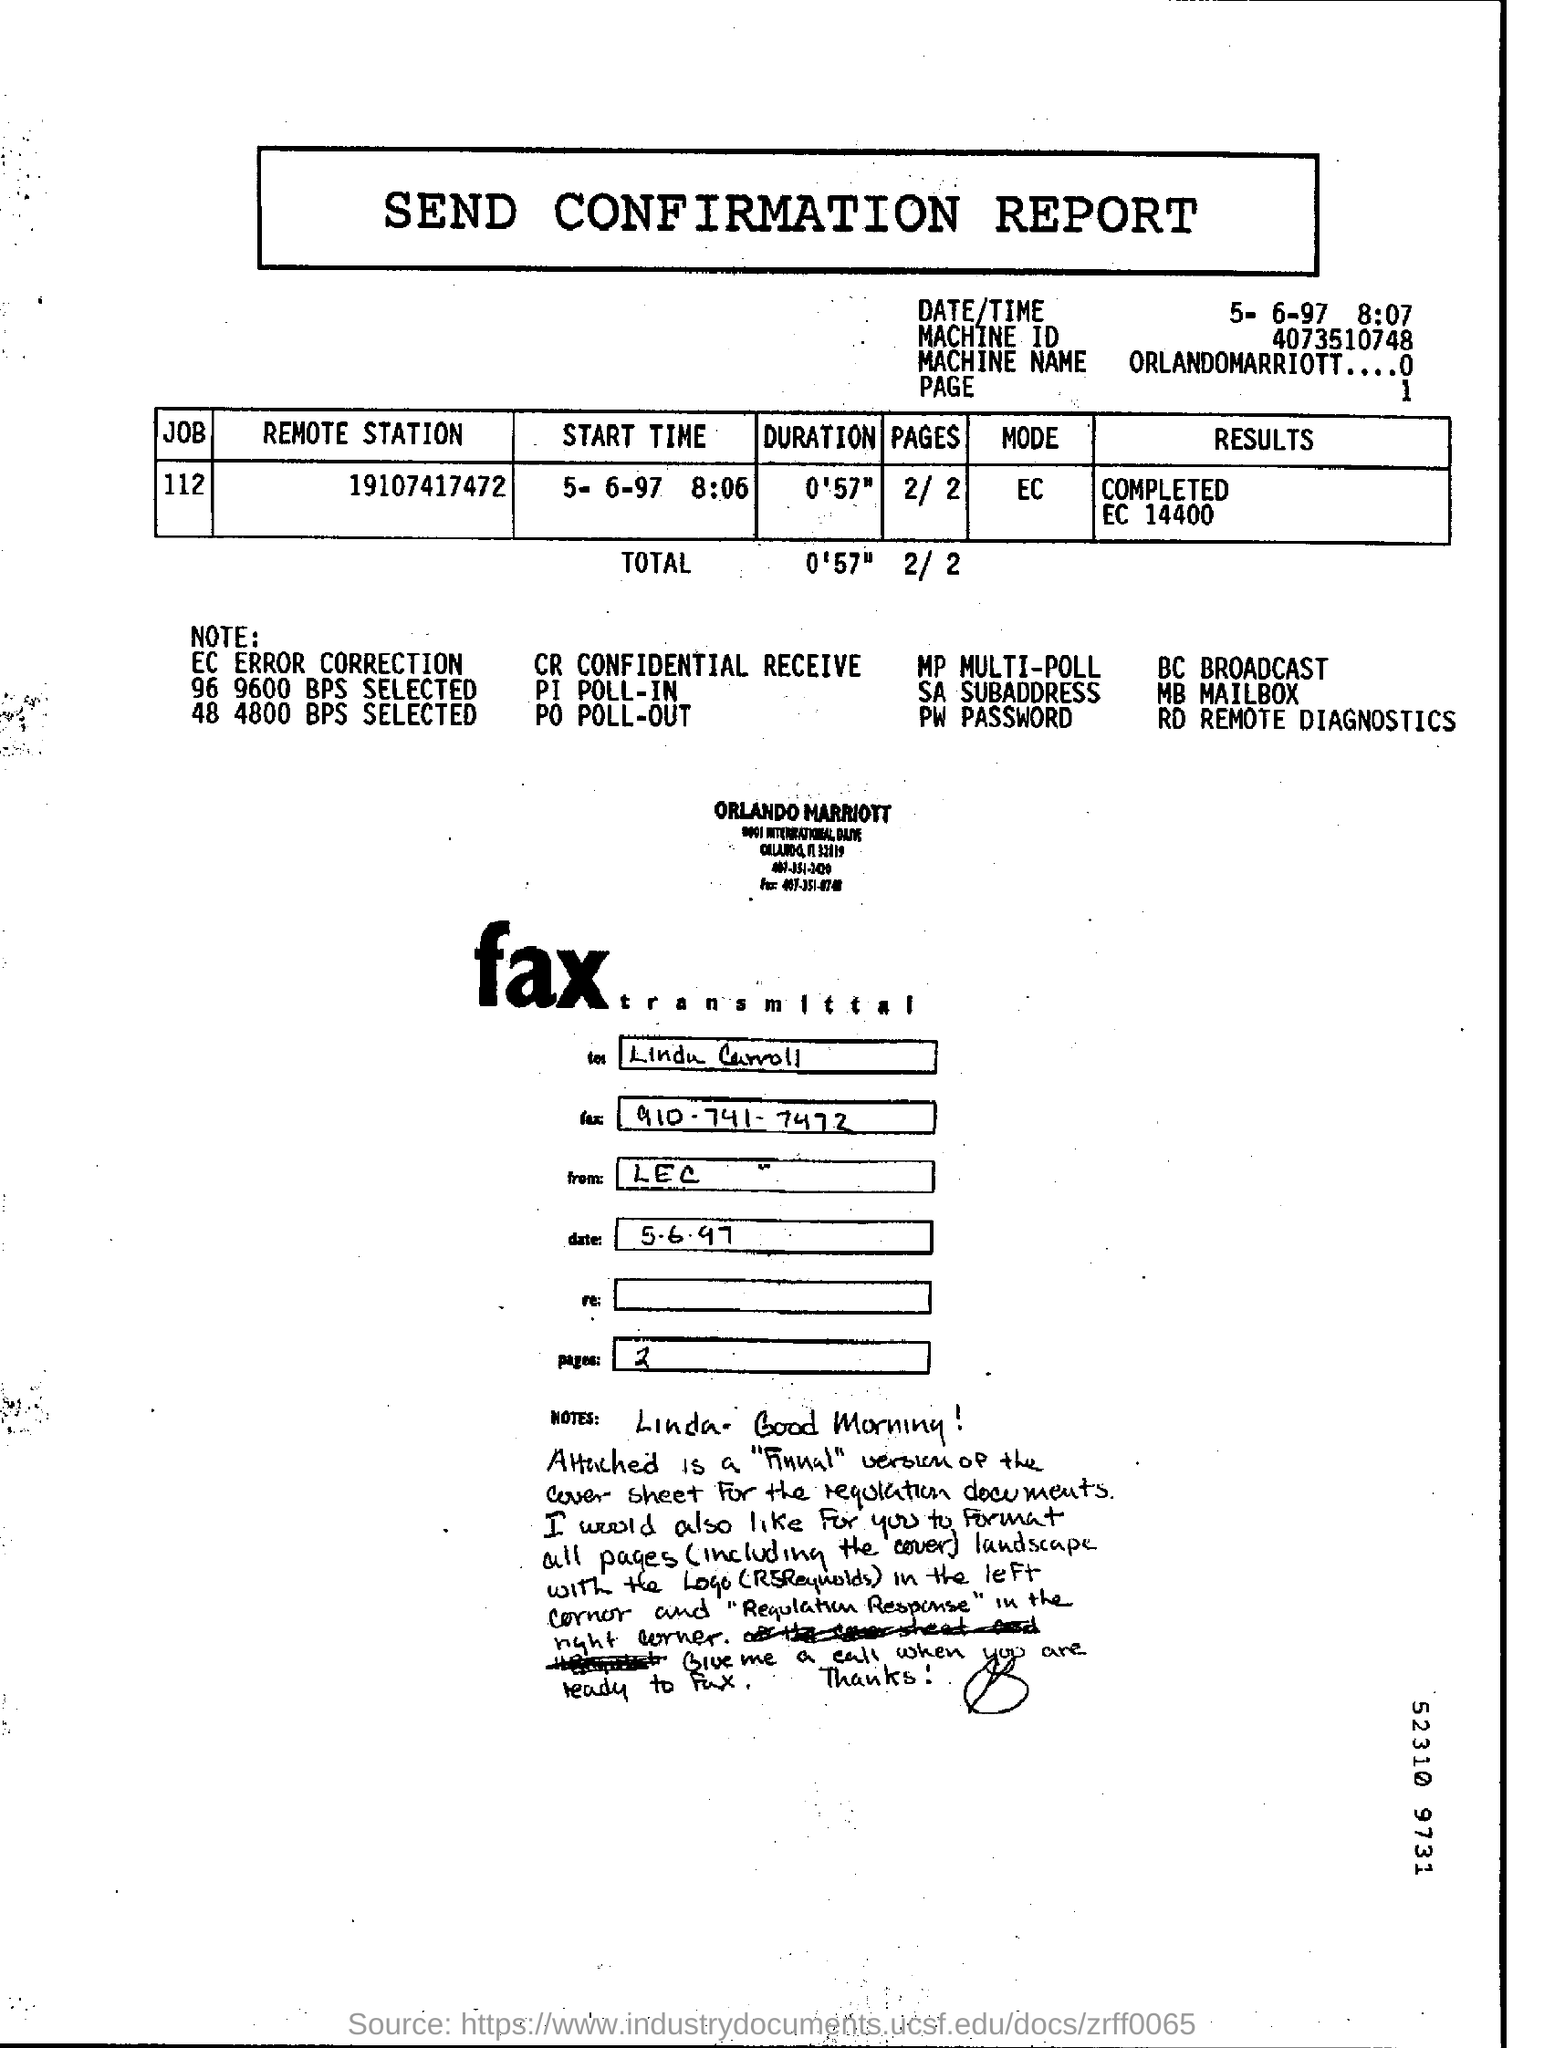Highlight a few significant elements in this photo. The job number given in the Send Confirmation report is 112. The FAX number mentioned in the fax transmittal is 910-741-7472. The Machine ID mentioned in the Send confirmation report is 4073510748. The machine name listed in the Send Confirmation report is OrlandoMarriott....0.. The report mentions a total duration of 0'57". 